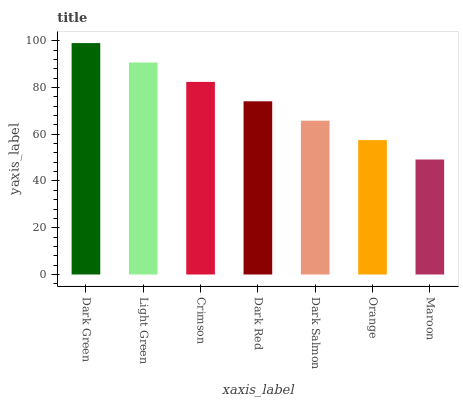Is Maroon the minimum?
Answer yes or no. Yes. Is Dark Green the maximum?
Answer yes or no. Yes. Is Light Green the minimum?
Answer yes or no. No. Is Light Green the maximum?
Answer yes or no. No. Is Dark Green greater than Light Green?
Answer yes or no. Yes. Is Light Green less than Dark Green?
Answer yes or no. Yes. Is Light Green greater than Dark Green?
Answer yes or no. No. Is Dark Green less than Light Green?
Answer yes or no. No. Is Dark Red the high median?
Answer yes or no. Yes. Is Dark Red the low median?
Answer yes or no. Yes. Is Orange the high median?
Answer yes or no. No. Is Light Green the low median?
Answer yes or no. No. 